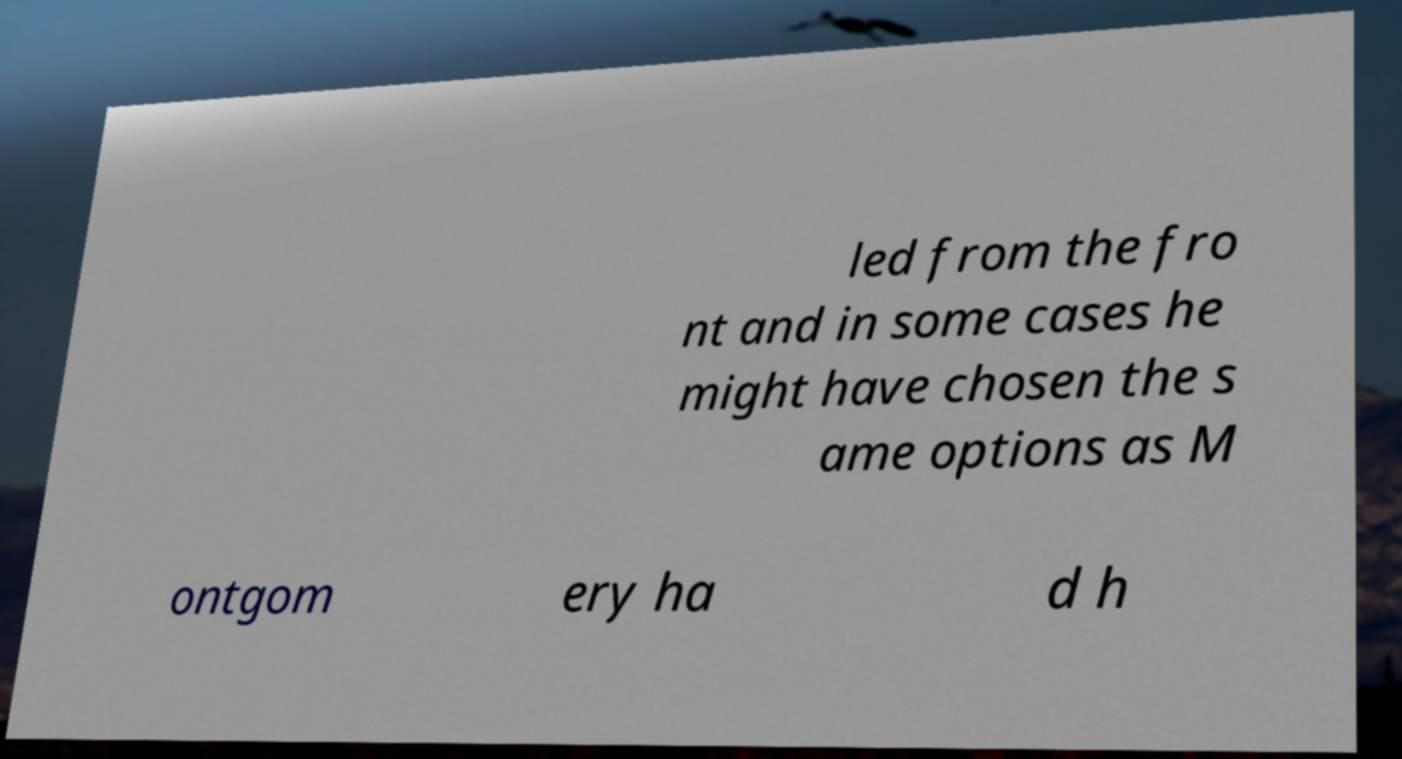Could you assist in decoding the text presented in this image and type it out clearly? led from the fro nt and in some cases he might have chosen the s ame options as M ontgom ery ha d h 